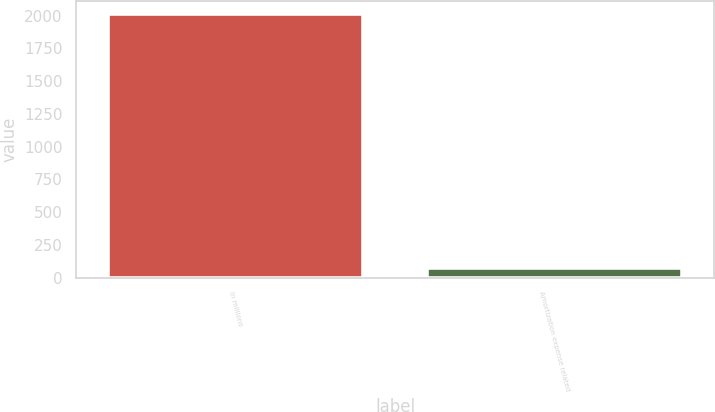Convert chart to OTSL. <chart><loc_0><loc_0><loc_500><loc_500><bar_chart><fcel>In millions<fcel>Amortization expense related<nl><fcel>2014<fcel>73<nl></chart> 